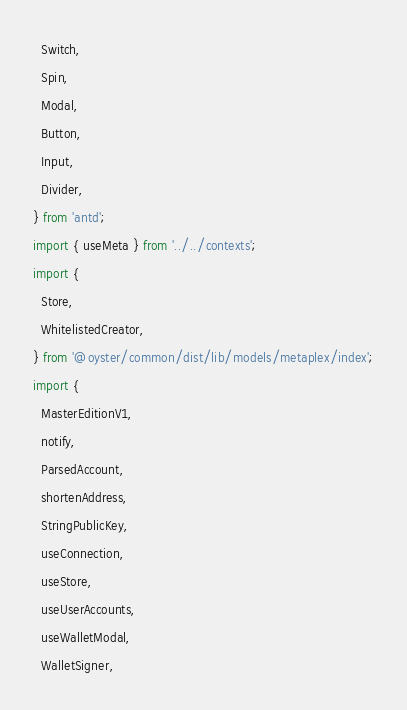Convert code to text. <code><loc_0><loc_0><loc_500><loc_500><_TypeScript_>  Switch,
  Spin,
  Modal,
  Button,
  Input,
  Divider,
} from 'antd';
import { useMeta } from '../../contexts';
import {
  Store,
  WhitelistedCreator,
} from '@oyster/common/dist/lib/models/metaplex/index';
import {
  MasterEditionV1,
  notify,
  ParsedAccount,
  shortenAddress,
  StringPublicKey,
  useConnection,
  useStore,
  useUserAccounts,
  useWalletModal,
  WalletSigner,</code> 